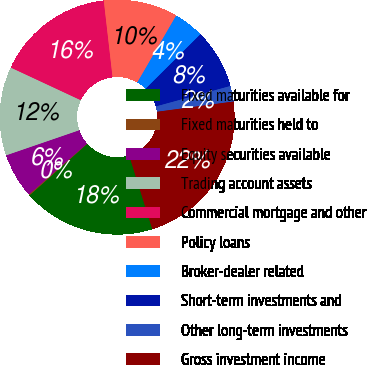<chart> <loc_0><loc_0><loc_500><loc_500><pie_chart><fcel>Fixed maturities available for<fcel>Fixed maturities held to<fcel>Equity securities available<fcel>Trading account assets<fcel>Commercial mortgage and other<fcel>Policy loans<fcel>Broker-dealer related<fcel>Short-term investments and<fcel>Other long-term investments<fcel>Gross investment income<nl><fcel>18.25%<fcel>0.14%<fcel>6.18%<fcel>12.21%<fcel>16.24%<fcel>10.2%<fcel>4.16%<fcel>8.19%<fcel>2.15%<fcel>22.28%<nl></chart> 